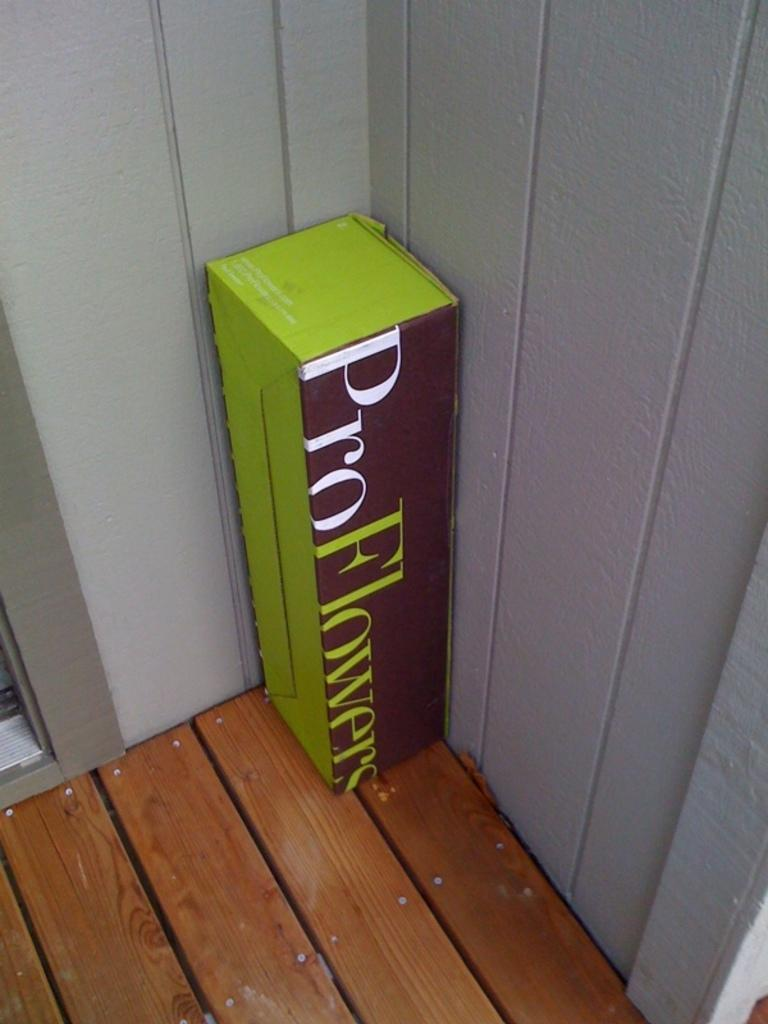<image>
Present a compact description of the photo's key features. The Pro Flowers box sits in the corner of the deck, outside of the house. 